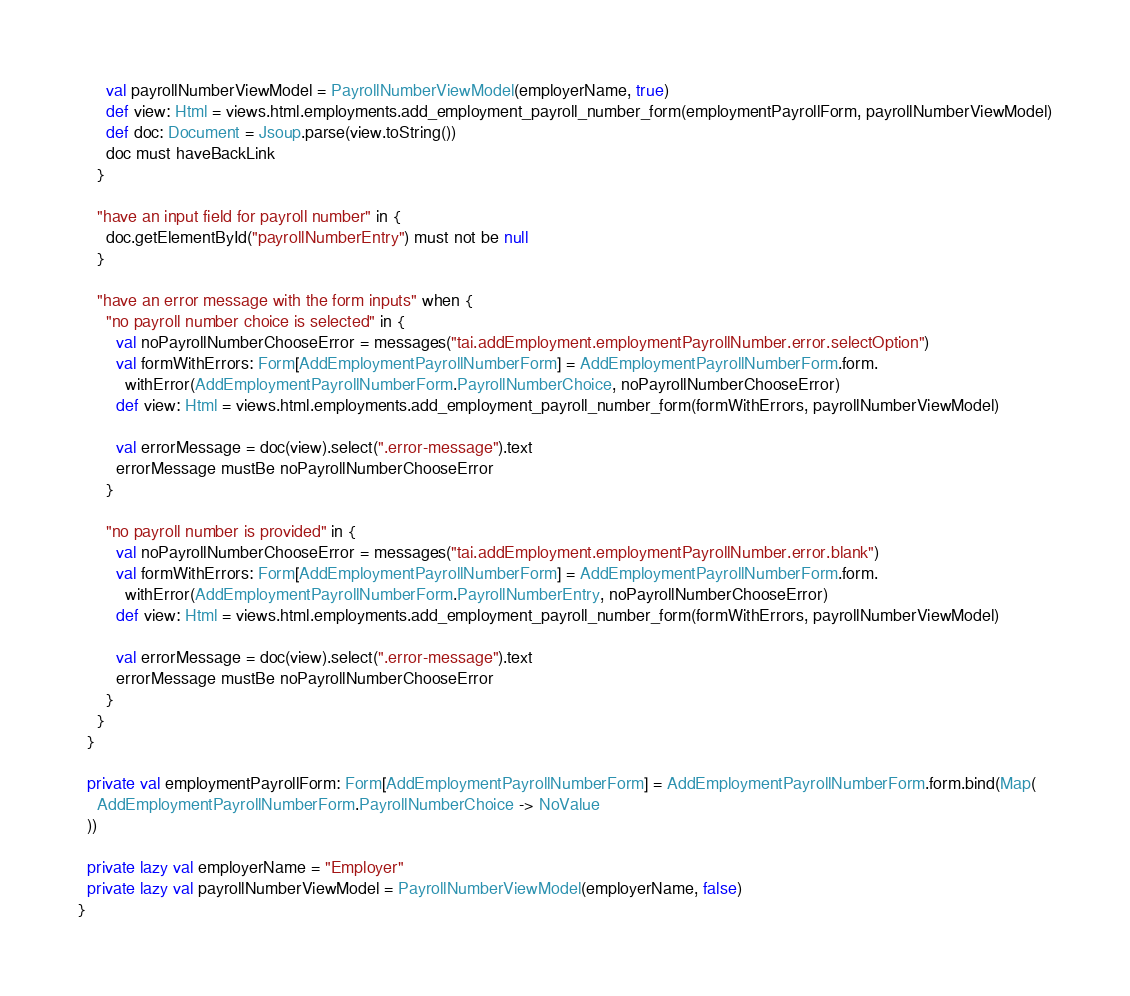<code> <loc_0><loc_0><loc_500><loc_500><_Scala_>      val payrollNumberViewModel = PayrollNumberViewModel(employerName, true)
      def view: Html = views.html.employments.add_employment_payroll_number_form(employmentPayrollForm, payrollNumberViewModel)
      def doc: Document = Jsoup.parse(view.toString())
      doc must haveBackLink
    }

    "have an input field for payroll number" in {
      doc.getElementById("payrollNumberEntry") must not be null
    }

    "have an error message with the form inputs" when {
      "no payroll number choice is selected" in {
        val noPayrollNumberChooseError = messages("tai.addEmployment.employmentPayrollNumber.error.selectOption")
        val formWithErrors: Form[AddEmploymentPayrollNumberForm] = AddEmploymentPayrollNumberForm.form.
          withError(AddEmploymentPayrollNumberForm.PayrollNumberChoice, noPayrollNumberChooseError)
        def view: Html = views.html.employments.add_employment_payroll_number_form(formWithErrors, payrollNumberViewModel)

        val errorMessage = doc(view).select(".error-message").text
        errorMessage mustBe noPayrollNumberChooseError
      }

      "no payroll number is provided" in {
        val noPayrollNumberChooseError = messages("tai.addEmployment.employmentPayrollNumber.error.blank")
        val formWithErrors: Form[AddEmploymentPayrollNumberForm] = AddEmploymentPayrollNumberForm.form.
          withError(AddEmploymentPayrollNumberForm.PayrollNumberEntry, noPayrollNumberChooseError)
        def view: Html = views.html.employments.add_employment_payroll_number_form(formWithErrors, payrollNumberViewModel)

        val errorMessage = doc(view).select(".error-message").text
        errorMessage mustBe noPayrollNumberChooseError
      }
    }
  }

  private val employmentPayrollForm: Form[AddEmploymentPayrollNumberForm] = AddEmploymentPayrollNumberForm.form.bind(Map(
    AddEmploymentPayrollNumberForm.PayrollNumberChoice -> NoValue
  ))

  private lazy val employerName = "Employer"
  private lazy val payrollNumberViewModel = PayrollNumberViewModel(employerName, false)
}
</code> 